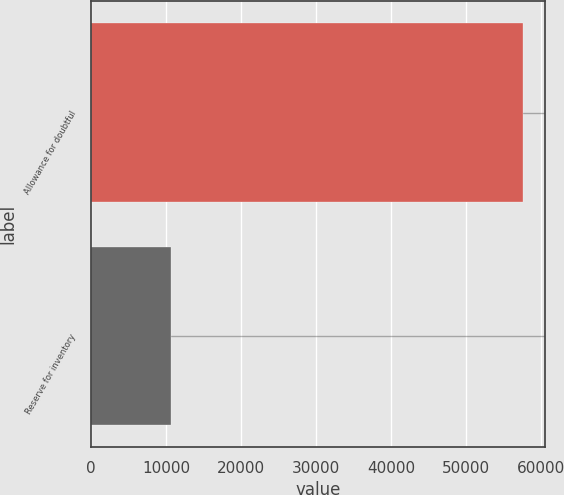<chart> <loc_0><loc_0><loc_500><loc_500><bar_chart><fcel>Allowance for doubtful<fcel>Reserve for inventory<nl><fcel>57573<fcel>10700<nl></chart> 